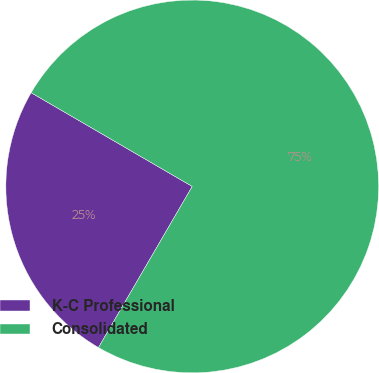Convert chart. <chart><loc_0><loc_0><loc_500><loc_500><pie_chart><fcel>K-C Professional<fcel>Consolidated<nl><fcel>25.0%<fcel>75.0%<nl></chart> 